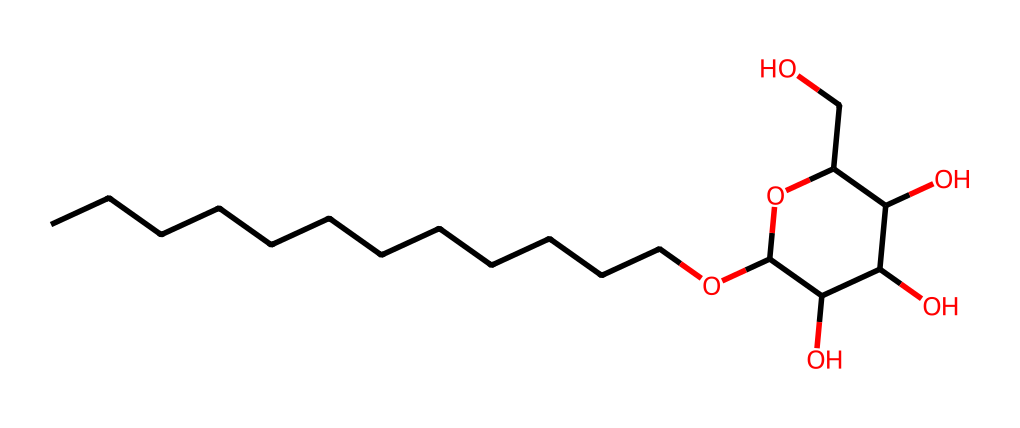What is the primary functional group in lauryl glucoside? The chemical structure shows multiple hydroxyl (–OH) groups, indicating the presence of alcohol functionalities, characteristic of glucosides.
Answer: hydroxyl How many carbon atoms are present in lauryl glucoside? By counting the 'C' symbols in the SMILES representation, there are 12 carbon atoms in the long hydrocarbon chain and more in the glucoside part. Total count is 15.
Answer: 15 What is the role of lauryl glucoside in cleaning solutions? Lauryl glucoside serves as a surfactant, allowing it to reduce surface tension, which helps in cleaning and spreading the liquid over surfaces.
Answer: surfactant What does the presence of oxygen atoms indicate about lauryl glucoside? The oxygen atoms are signs of functional groups like ether and hydroxyl, which contribute to the surfactant's mildness and solubility in water.
Answer: mildness and solubility How many hydroxyl groups are present in lauryl glucoside? The structure reveals four hydroxyl (-OH) groups involved in forming the glucoside, indicating multiple sites for hydrogen bonding.
Answer: 4 